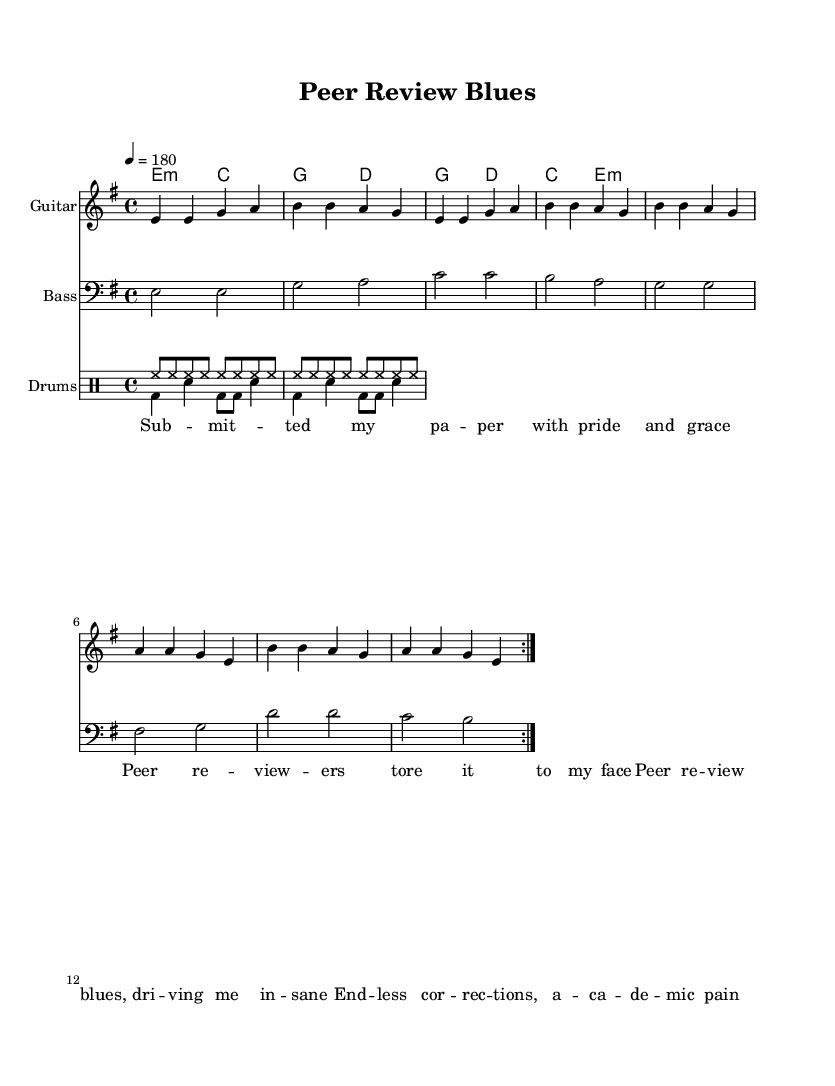What is the key signature of this music? The key signature is indicated at the beginning of the staff, where there are no sharps or flats, which designates E minor as the key.
Answer: E minor What is the time signature of this music? The time signature is displayed after the key signature at the beginning of the music and shows 4/4, indicating four beats per measure.
Answer: 4/4 What is the tempo marking of this piece? The tempo is located above the staff, and it indicates a speed of 180 beats per minute, represented as "4 = 180."
Answer: 180 How many measures are in the guitar part? By counting the repeated sections in the guitar part, there are 8 measures shown through the triplet formatting of the verse and chorus, with two complete iterations of the verse and chorus.
Answer: 8 What is the primary musical form of this piece? The music structure follows a common rock format of verses and choruses, specifically marked through the repeated sections of the verse and chorus, emphasizing a simple verse-chorus structure.
Answer: Verse-Chorus What drum patterns are used throughout the piece? The drum part has two distinct patterns: one for drum fills (marked as "drum_up") which has a consistent hi-hat pattern, and another "drum_down" which shows a bass and snare pattern for the beats of the song.
Answer: Hi-hat and bass-snare What theme is expressed through the lyrics? The lyrics discuss the frustrations of the peer review process in academia, highlighting the challenges and stress involved in submitting papers and receiving critiques from reviewers.
Answer: Peer review frustrations 